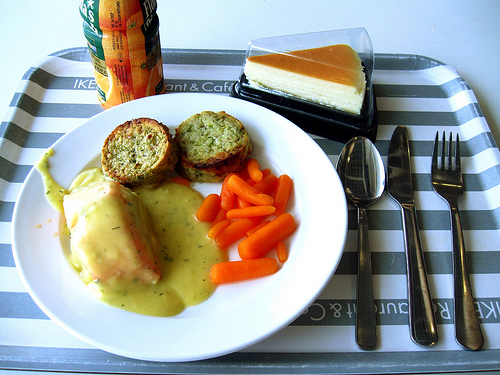<image>
Can you confirm if the carrots is behind the gravy? No. The carrots is not behind the gravy. From this viewpoint, the carrots appears to be positioned elsewhere in the scene. Where is the carrots in relation to the spoon? Is it to the left of the spoon? Yes. From this viewpoint, the carrots is positioned to the left side relative to the spoon. 